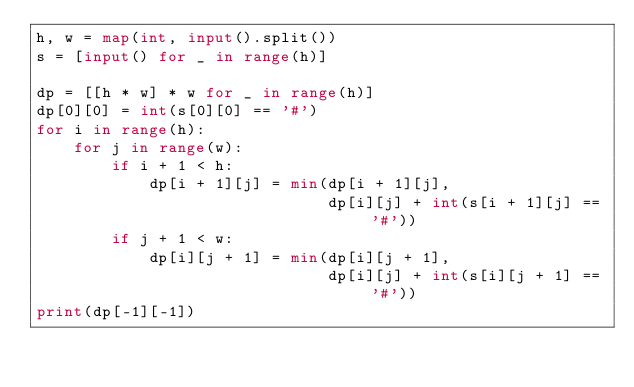<code> <loc_0><loc_0><loc_500><loc_500><_Python_>h, w = map(int, input().split())
s = [input() for _ in range(h)]

dp = [[h * w] * w for _ in range(h)]
dp[0][0] = int(s[0][0] == '#')
for i in range(h):
    for j in range(w):
        if i + 1 < h:
            dp[i + 1][j] = min(dp[i + 1][j],
                               dp[i][j] + int(s[i + 1][j] == '#'))
        if j + 1 < w:
            dp[i][j + 1] = min(dp[i][j + 1],
                               dp[i][j] + int(s[i][j + 1] == '#'))
print(dp[-1][-1])
</code> 